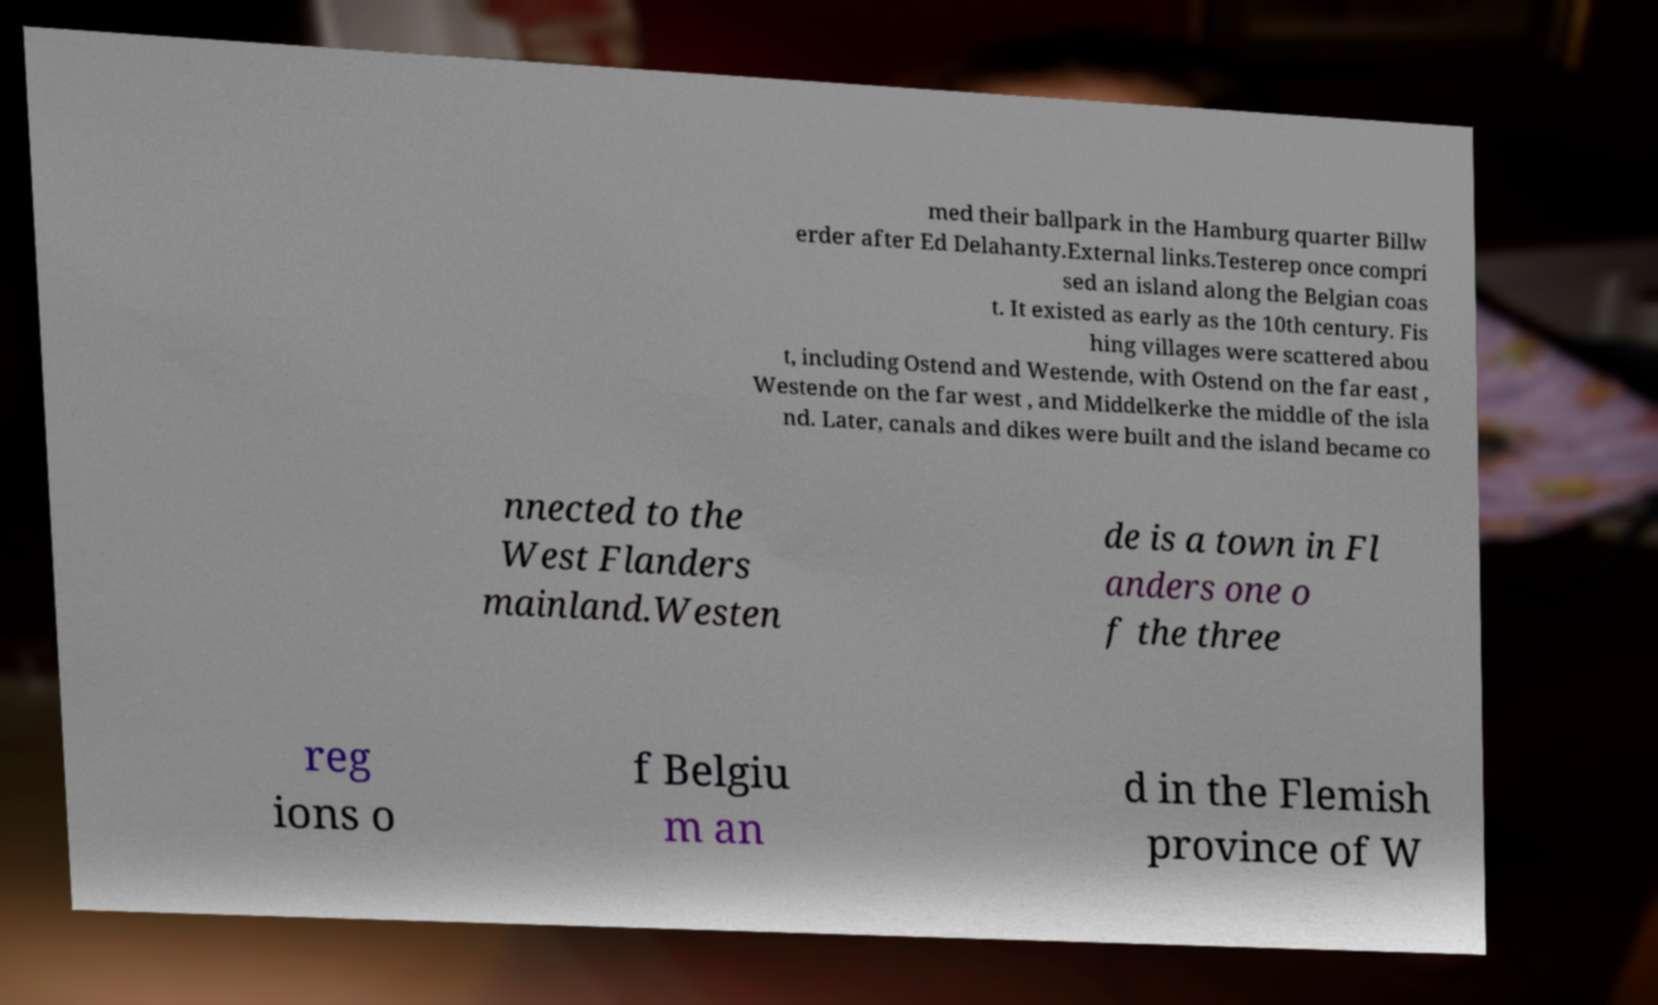For documentation purposes, I need the text within this image transcribed. Could you provide that? med their ballpark in the Hamburg quarter Billw erder after Ed Delahanty.External links.Testerep once compri sed an island along the Belgian coas t. It existed as early as the 10th century. Fis hing villages were scattered abou t, including Ostend and Westende, with Ostend on the far east , Westende on the far west , and Middelkerke the middle of the isla nd. Later, canals and dikes were built and the island became co nnected to the West Flanders mainland.Westen de is a town in Fl anders one o f the three reg ions o f Belgiu m an d in the Flemish province of W 